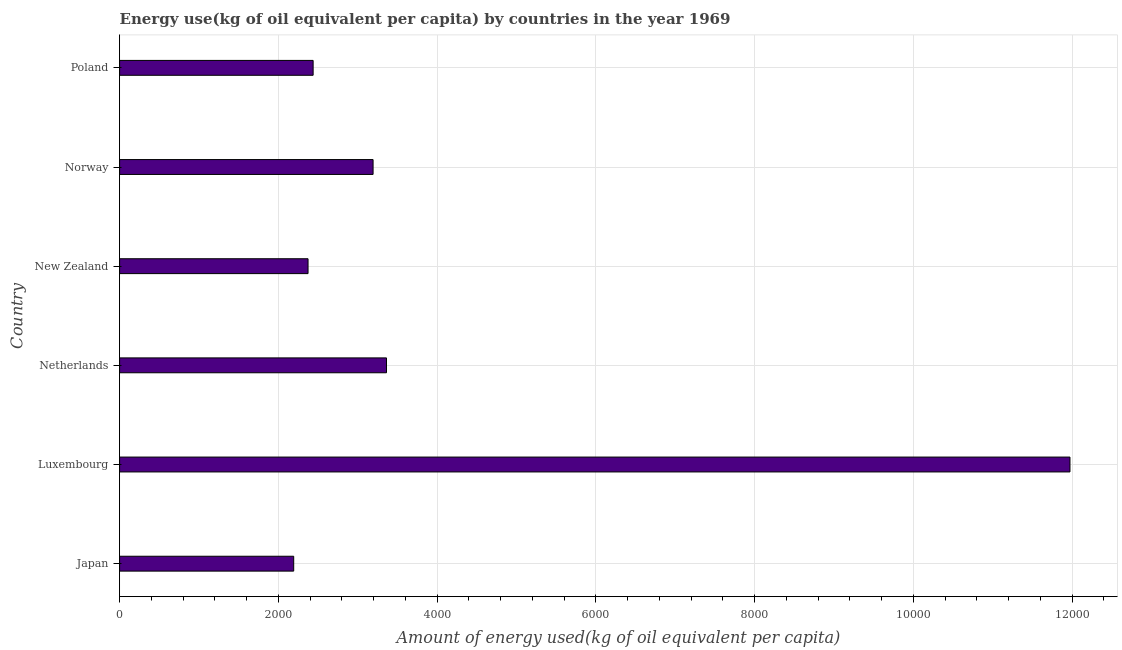Does the graph contain any zero values?
Provide a succinct answer. No. Does the graph contain grids?
Provide a succinct answer. Yes. What is the title of the graph?
Give a very brief answer. Energy use(kg of oil equivalent per capita) by countries in the year 1969. What is the label or title of the X-axis?
Your response must be concise. Amount of energy used(kg of oil equivalent per capita). What is the amount of energy used in Luxembourg?
Provide a succinct answer. 1.20e+04. Across all countries, what is the maximum amount of energy used?
Give a very brief answer. 1.20e+04. Across all countries, what is the minimum amount of energy used?
Ensure brevity in your answer.  2193.61. In which country was the amount of energy used maximum?
Keep it short and to the point. Luxembourg. What is the sum of the amount of energy used?
Your answer should be very brief. 2.55e+04. What is the difference between the amount of energy used in Luxembourg and Netherlands?
Your answer should be very brief. 8611.41. What is the average amount of energy used per country?
Provide a succinct answer. 4256.14. What is the median amount of energy used?
Your answer should be compact. 2816.01. In how many countries, is the amount of energy used greater than 2000 kg?
Keep it short and to the point. 6. What is the ratio of the amount of energy used in Japan to that in Netherlands?
Keep it short and to the point. 0.65. What is the difference between the highest and the second highest amount of energy used?
Keep it short and to the point. 8611.41. Is the sum of the amount of energy used in Luxembourg and New Zealand greater than the maximum amount of energy used across all countries?
Your answer should be compact. Yes. What is the difference between the highest and the lowest amount of energy used?
Your response must be concise. 9780.58. How many bars are there?
Your response must be concise. 6. Are all the bars in the graph horizontal?
Keep it short and to the point. Yes. Are the values on the major ticks of X-axis written in scientific E-notation?
Provide a succinct answer. No. What is the Amount of energy used(kg of oil equivalent per capita) in Japan?
Provide a succinct answer. 2193.61. What is the Amount of energy used(kg of oil equivalent per capita) in Luxembourg?
Ensure brevity in your answer.  1.20e+04. What is the Amount of energy used(kg of oil equivalent per capita) of Netherlands?
Your answer should be compact. 3362.79. What is the Amount of energy used(kg of oil equivalent per capita) of New Zealand?
Your answer should be compact. 2374.23. What is the Amount of energy used(kg of oil equivalent per capita) in Norway?
Your response must be concise. 3193.66. What is the Amount of energy used(kg of oil equivalent per capita) in Poland?
Keep it short and to the point. 2438.37. What is the difference between the Amount of energy used(kg of oil equivalent per capita) in Japan and Luxembourg?
Your answer should be very brief. -9780.58. What is the difference between the Amount of energy used(kg of oil equivalent per capita) in Japan and Netherlands?
Give a very brief answer. -1169.18. What is the difference between the Amount of energy used(kg of oil equivalent per capita) in Japan and New Zealand?
Offer a terse response. -180.62. What is the difference between the Amount of energy used(kg of oil equivalent per capita) in Japan and Norway?
Offer a terse response. -1000.04. What is the difference between the Amount of energy used(kg of oil equivalent per capita) in Japan and Poland?
Keep it short and to the point. -244.76. What is the difference between the Amount of energy used(kg of oil equivalent per capita) in Luxembourg and Netherlands?
Ensure brevity in your answer.  8611.41. What is the difference between the Amount of energy used(kg of oil equivalent per capita) in Luxembourg and New Zealand?
Keep it short and to the point. 9599.96. What is the difference between the Amount of energy used(kg of oil equivalent per capita) in Luxembourg and Norway?
Keep it short and to the point. 8780.54. What is the difference between the Amount of energy used(kg of oil equivalent per capita) in Luxembourg and Poland?
Provide a succinct answer. 9535.83. What is the difference between the Amount of energy used(kg of oil equivalent per capita) in Netherlands and New Zealand?
Ensure brevity in your answer.  988.56. What is the difference between the Amount of energy used(kg of oil equivalent per capita) in Netherlands and Norway?
Provide a short and direct response. 169.13. What is the difference between the Amount of energy used(kg of oil equivalent per capita) in Netherlands and Poland?
Give a very brief answer. 924.42. What is the difference between the Amount of energy used(kg of oil equivalent per capita) in New Zealand and Norway?
Your answer should be very brief. -819.43. What is the difference between the Amount of energy used(kg of oil equivalent per capita) in New Zealand and Poland?
Your answer should be very brief. -64.14. What is the difference between the Amount of energy used(kg of oil equivalent per capita) in Norway and Poland?
Give a very brief answer. 755.29. What is the ratio of the Amount of energy used(kg of oil equivalent per capita) in Japan to that in Luxembourg?
Provide a succinct answer. 0.18. What is the ratio of the Amount of energy used(kg of oil equivalent per capita) in Japan to that in Netherlands?
Offer a terse response. 0.65. What is the ratio of the Amount of energy used(kg of oil equivalent per capita) in Japan to that in New Zealand?
Keep it short and to the point. 0.92. What is the ratio of the Amount of energy used(kg of oil equivalent per capita) in Japan to that in Norway?
Offer a terse response. 0.69. What is the ratio of the Amount of energy used(kg of oil equivalent per capita) in Luxembourg to that in Netherlands?
Ensure brevity in your answer.  3.56. What is the ratio of the Amount of energy used(kg of oil equivalent per capita) in Luxembourg to that in New Zealand?
Keep it short and to the point. 5.04. What is the ratio of the Amount of energy used(kg of oil equivalent per capita) in Luxembourg to that in Norway?
Make the answer very short. 3.75. What is the ratio of the Amount of energy used(kg of oil equivalent per capita) in Luxembourg to that in Poland?
Provide a succinct answer. 4.91. What is the ratio of the Amount of energy used(kg of oil equivalent per capita) in Netherlands to that in New Zealand?
Offer a very short reply. 1.42. What is the ratio of the Amount of energy used(kg of oil equivalent per capita) in Netherlands to that in Norway?
Make the answer very short. 1.05. What is the ratio of the Amount of energy used(kg of oil equivalent per capita) in Netherlands to that in Poland?
Your answer should be very brief. 1.38. What is the ratio of the Amount of energy used(kg of oil equivalent per capita) in New Zealand to that in Norway?
Provide a succinct answer. 0.74. What is the ratio of the Amount of energy used(kg of oil equivalent per capita) in New Zealand to that in Poland?
Ensure brevity in your answer.  0.97. What is the ratio of the Amount of energy used(kg of oil equivalent per capita) in Norway to that in Poland?
Offer a very short reply. 1.31. 